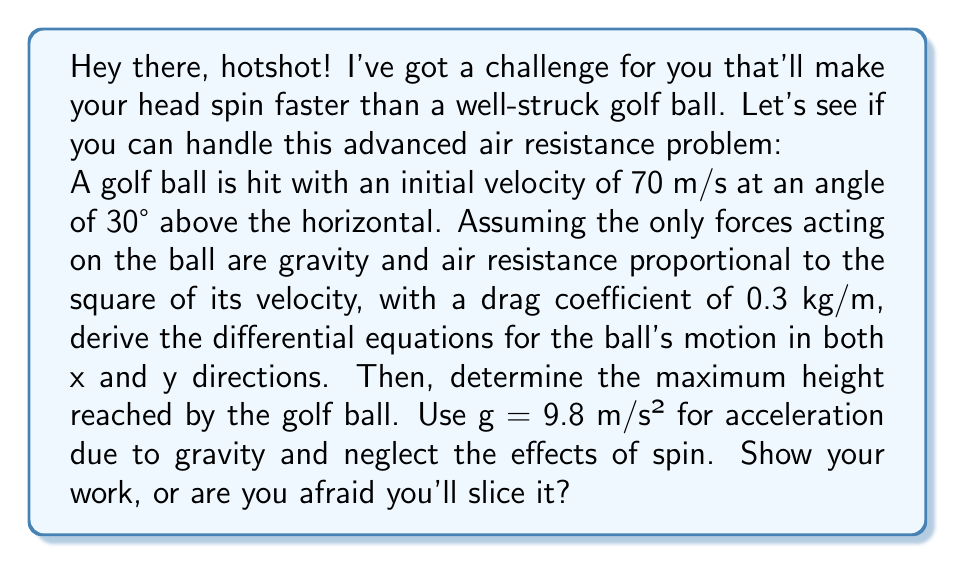Could you help me with this problem? Alright, let's break this down step-by-step:

1) First, let's define our variables:
   $x$ and $y$ for horizontal and vertical positions
   $v_x$ and $v_y$ for horizontal and vertical velocities
   $m$ for mass of the golf ball (let's assume 0.046 kg)
   $k$ for the drag coefficient (given as 0.3 kg/m)

2) The forces acting on the ball are:
   Gravity: $F_g = -mg$ (in y-direction)
   Air resistance: $F_d = -kv^2$ (opposite to velocity)

3) We can break down the air resistance into x and y components:
   $F_{dx} = -kv^2 \cos \theta = -kv v_x$
   $F_{dy} = -kv^2 \sin \theta = -kv v_y$
   where $v = \sqrt{v_x^2 + v_y^2}$

4) Now, we can write the differential equations using Newton's Second Law:
   In x-direction: $m\frac{d^2x}{dt^2} = -kv\frac{dx}{dt}$
   In y-direction: $m\frac{d^2y}{dt^2} = -kv\frac{dy}{dt} - mg$

5) Simplifying:
   $$\frac{d^2x}{dt^2} = -\frac{k}{m}v\frac{dx}{dt}$$
   $$\frac{d^2y}{dt^2} = -\frac{k}{m}v\frac{dy}{dt} - g$$

6) To find the maximum height, we need to solve these equations numerically. However, we can estimate it using the initial velocity components:

   $v_{x0} = 70 \cos 30° = 60.62$ m/s
   $v_{y0} = 70 \sin 30° = 35$ m/s

7) Neglecting air resistance for a rough estimate, we can use the equation:
   $y_{max} = \frac{v_{y0}^2}{2g}$

8) Plugging in our values:
   $y_{max} = \frac{35^2}{2(9.8)} \approx 62.5$ m

9) However, due to air resistance, the actual maximum height will be less than this. A more accurate result would require numerical integration of the differential equations.
Answer: Differential equations: $\frac{d^2x}{dt^2} = -\frac{k}{m}v\frac{dx}{dt}$, $\frac{d^2y}{dt^2} = -\frac{k}{m}v\frac{dy}{dt} - g$. Estimated maximum height (neglecting air resistance): 62.5 m. Actual maximum height will be lower due to air resistance. 